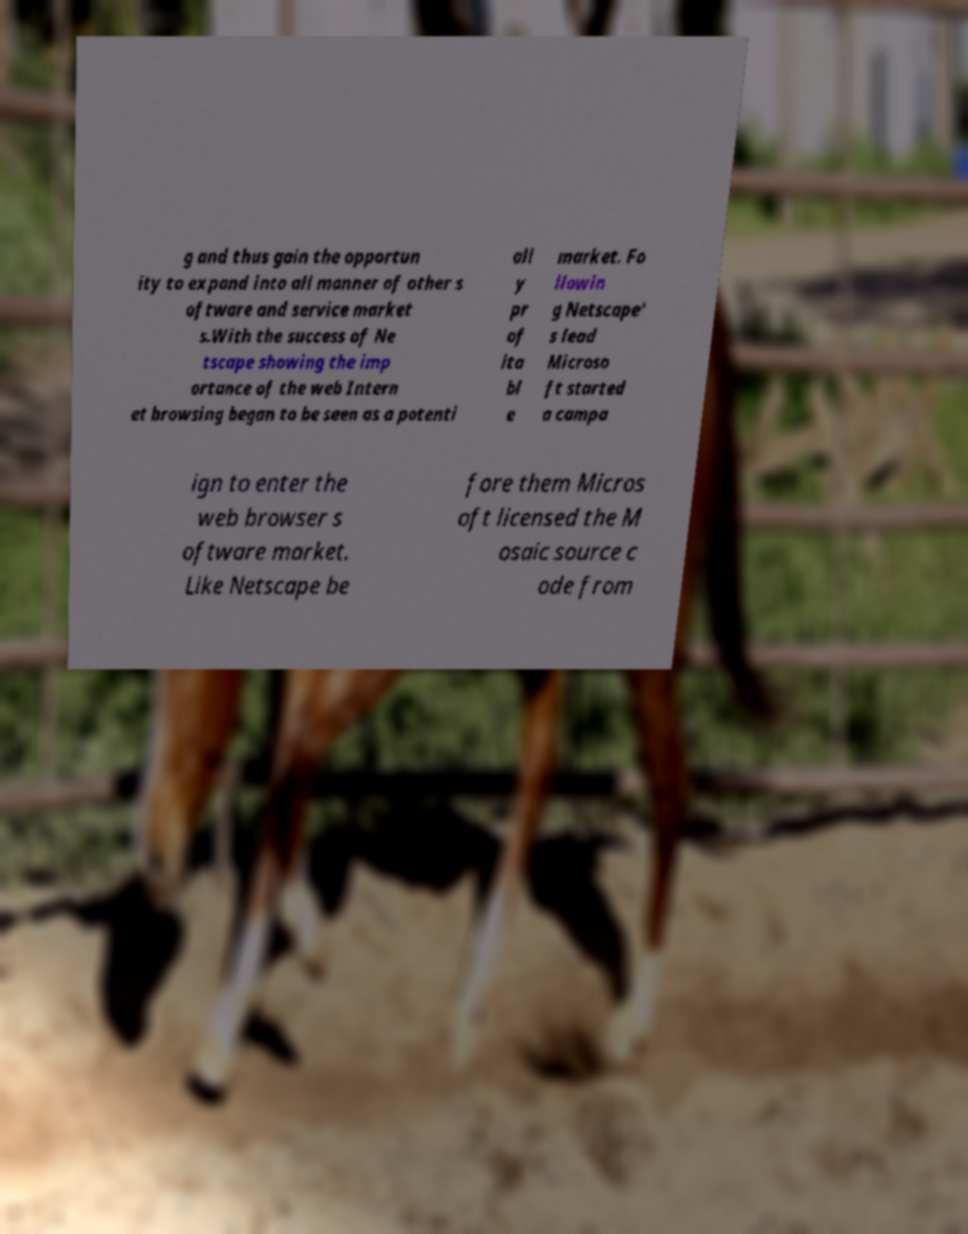I need the written content from this picture converted into text. Can you do that? g and thus gain the opportun ity to expand into all manner of other s oftware and service market s.With the success of Ne tscape showing the imp ortance of the web Intern et browsing began to be seen as a potenti all y pr of ita bl e market. Fo llowin g Netscape' s lead Microso ft started a campa ign to enter the web browser s oftware market. Like Netscape be fore them Micros oft licensed the M osaic source c ode from 